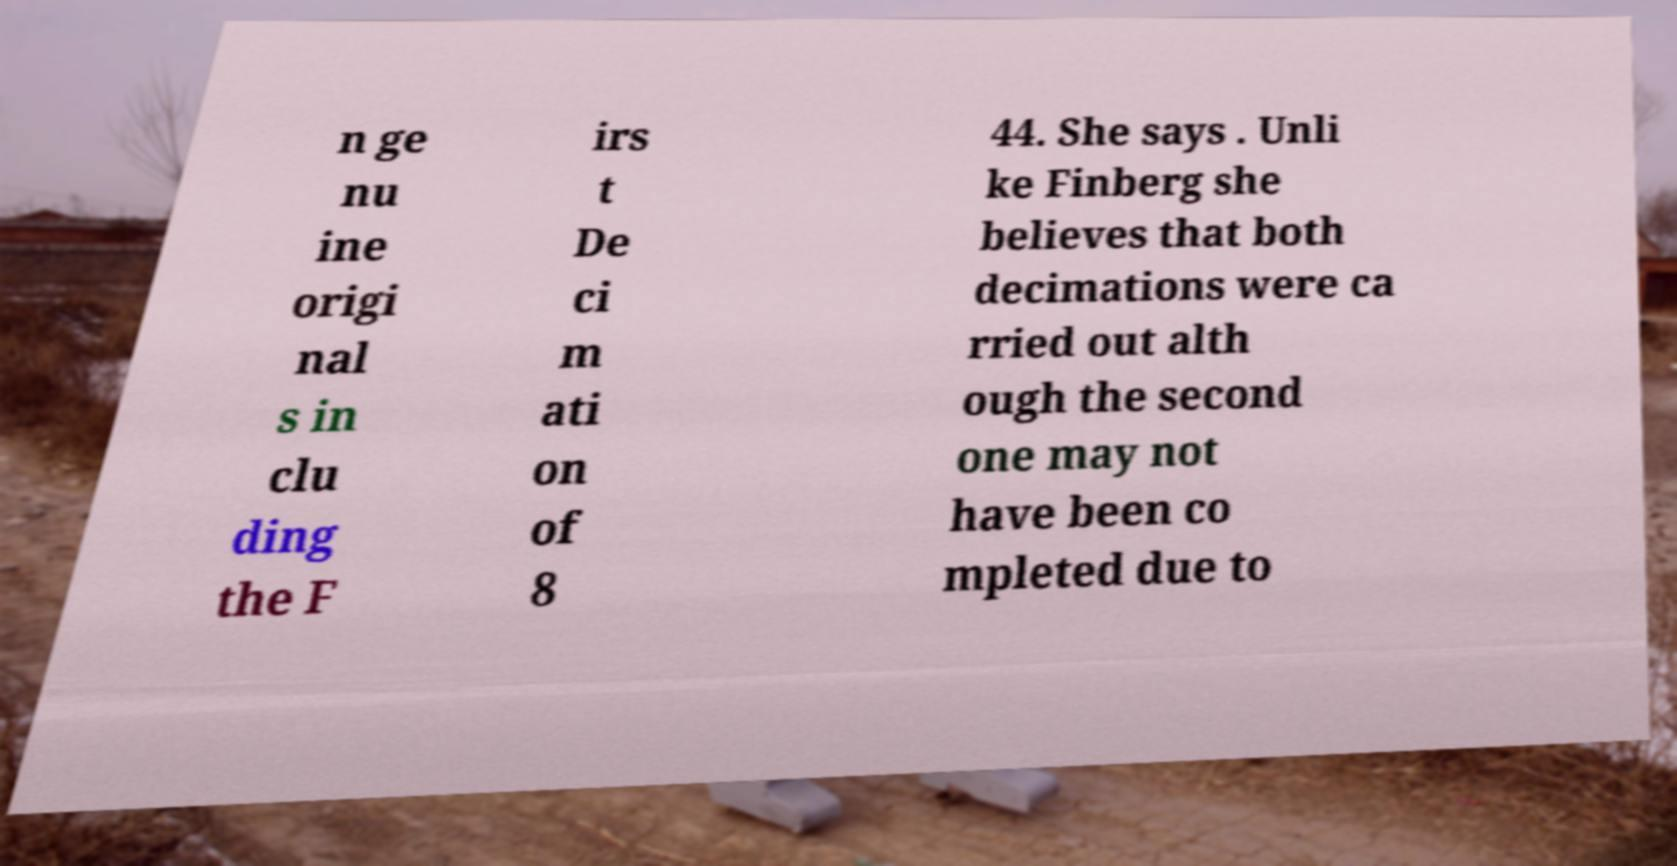I need the written content from this picture converted into text. Can you do that? n ge nu ine origi nal s in clu ding the F irs t De ci m ati on of 8 44. She says . Unli ke Finberg she believes that both decimations were ca rried out alth ough the second one may not have been co mpleted due to 